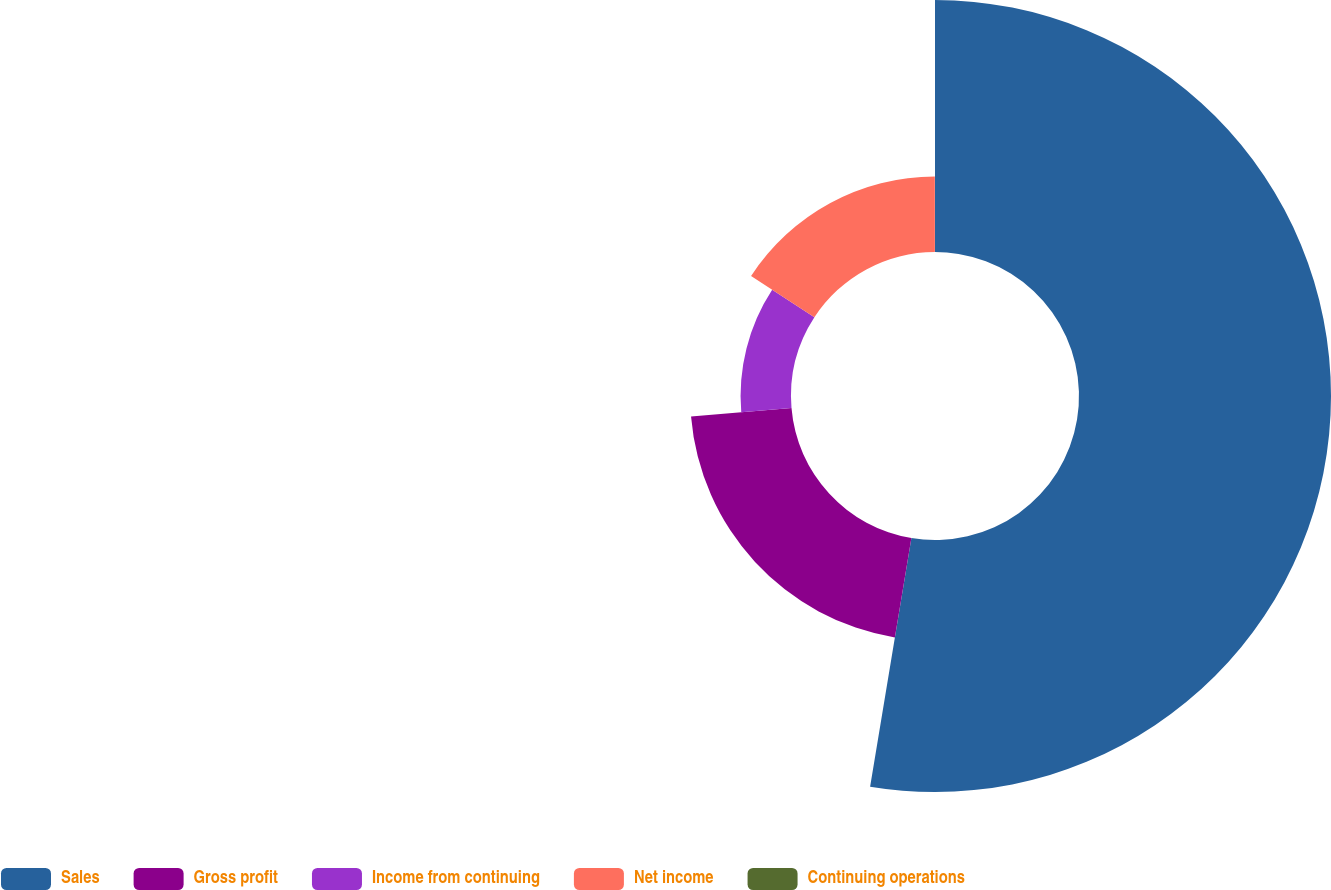<chart> <loc_0><loc_0><loc_500><loc_500><pie_chart><fcel>Sales<fcel>Gross profit<fcel>Income from continuing<fcel>Net income<fcel>Continuing operations<nl><fcel>52.62%<fcel>21.05%<fcel>10.53%<fcel>15.79%<fcel>0.01%<nl></chart> 